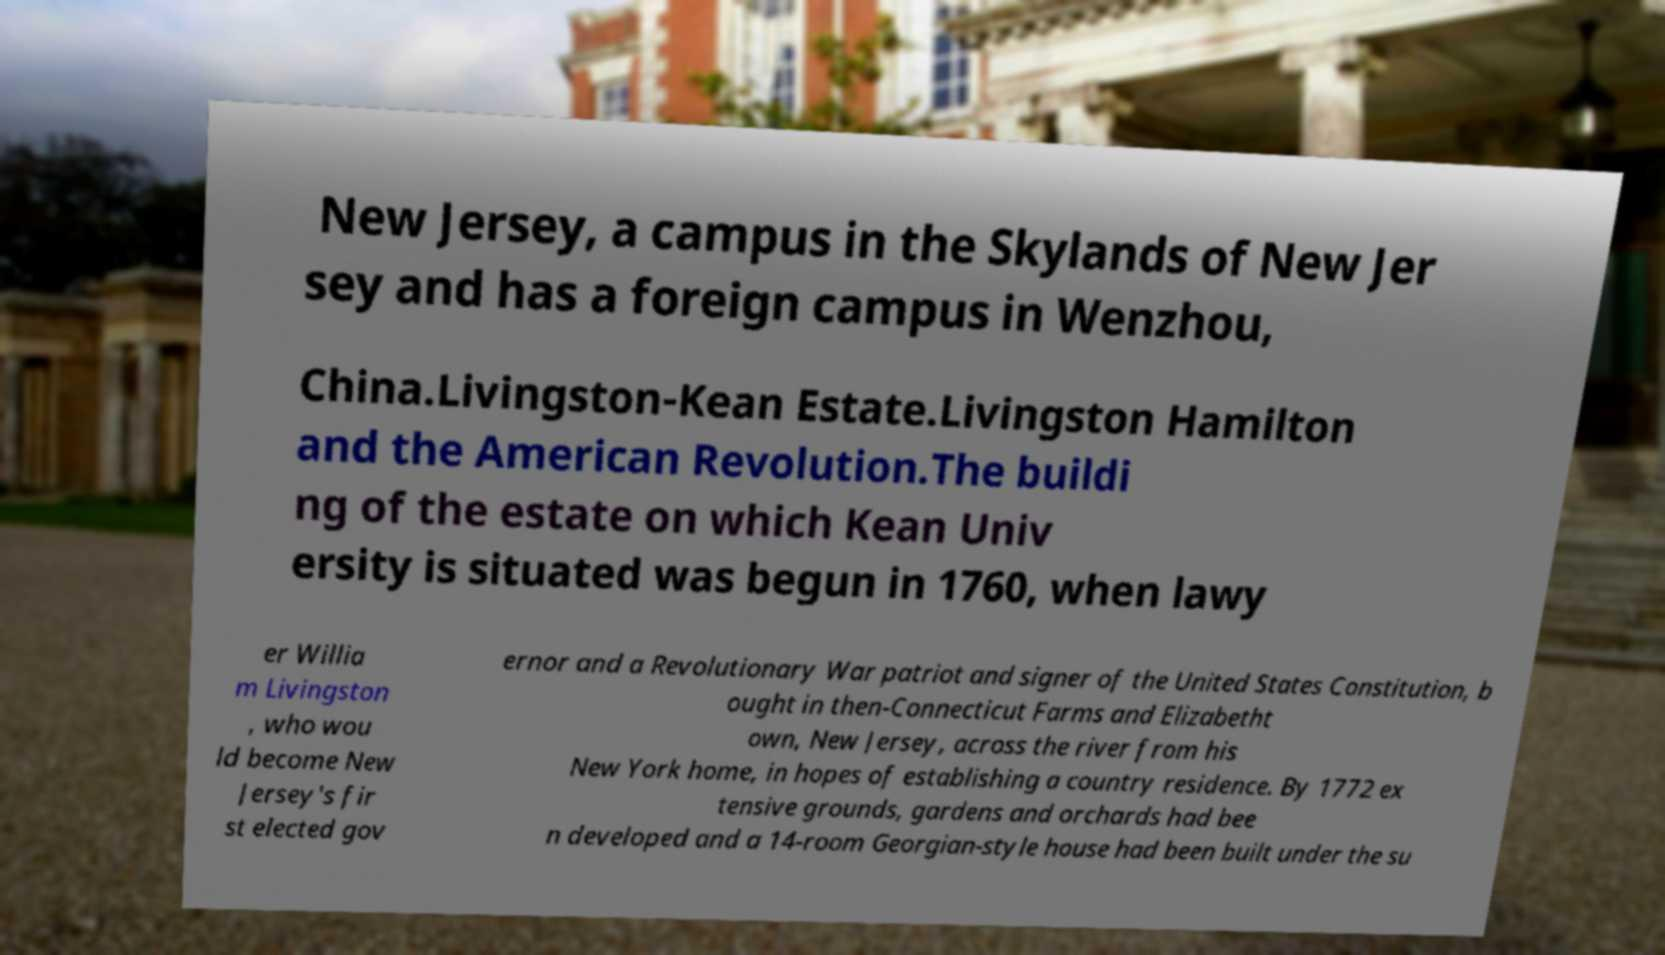What messages or text are displayed in this image? I need them in a readable, typed format. New Jersey, a campus in the Skylands of New Jer sey and has a foreign campus in Wenzhou, China.Livingston-Kean Estate.Livingston Hamilton and the American Revolution.The buildi ng of the estate on which Kean Univ ersity is situated was begun in 1760, when lawy er Willia m Livingston , who wou ld become New Jersey's fir st elected gov ernor and a Revolutionary War patriot and signer of the United States Constitution, b ought in then-Connecticut Farms and Elizabetht own, New Jersey, across the river from his New York home, in hopes of establishing a country residence. By 1772 ex tensive grounds, gardens and orchards had bee n developed and a 14-room Georgian-style house had been built under the su 